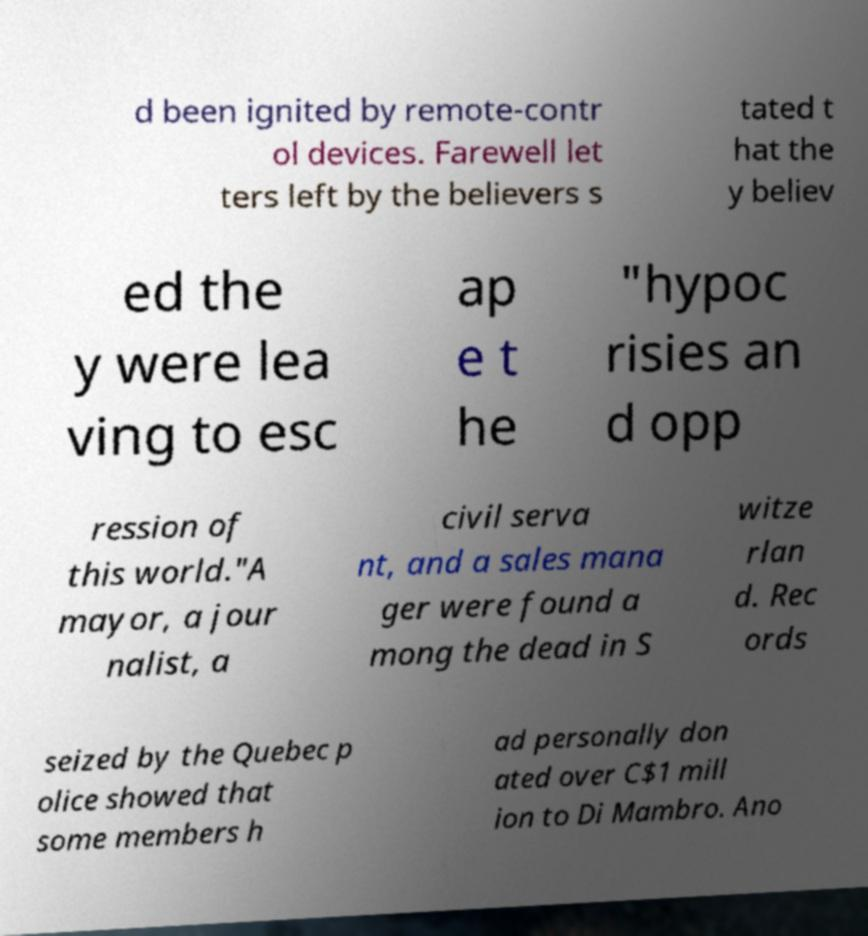Can you read and provide the text displayed in the image?This photo seems to have some interesting text. Can you extract and type it out for me? d been ignited by remote-contr ol devices. Farewell let ters left by the believers s tated t hat the y believ ed the y were lea ving to esc ap e t he "hypoc risies an d opp ression of this world."A mayor, a jour nalist, a civil serva nt, and a sales mana ger were found a mong the dead in S witze rlan d. Rec ords seized by the Quebec p olice showed that some members h ad personally don ated over C$1 mill ion to Di Mambro. Ano 